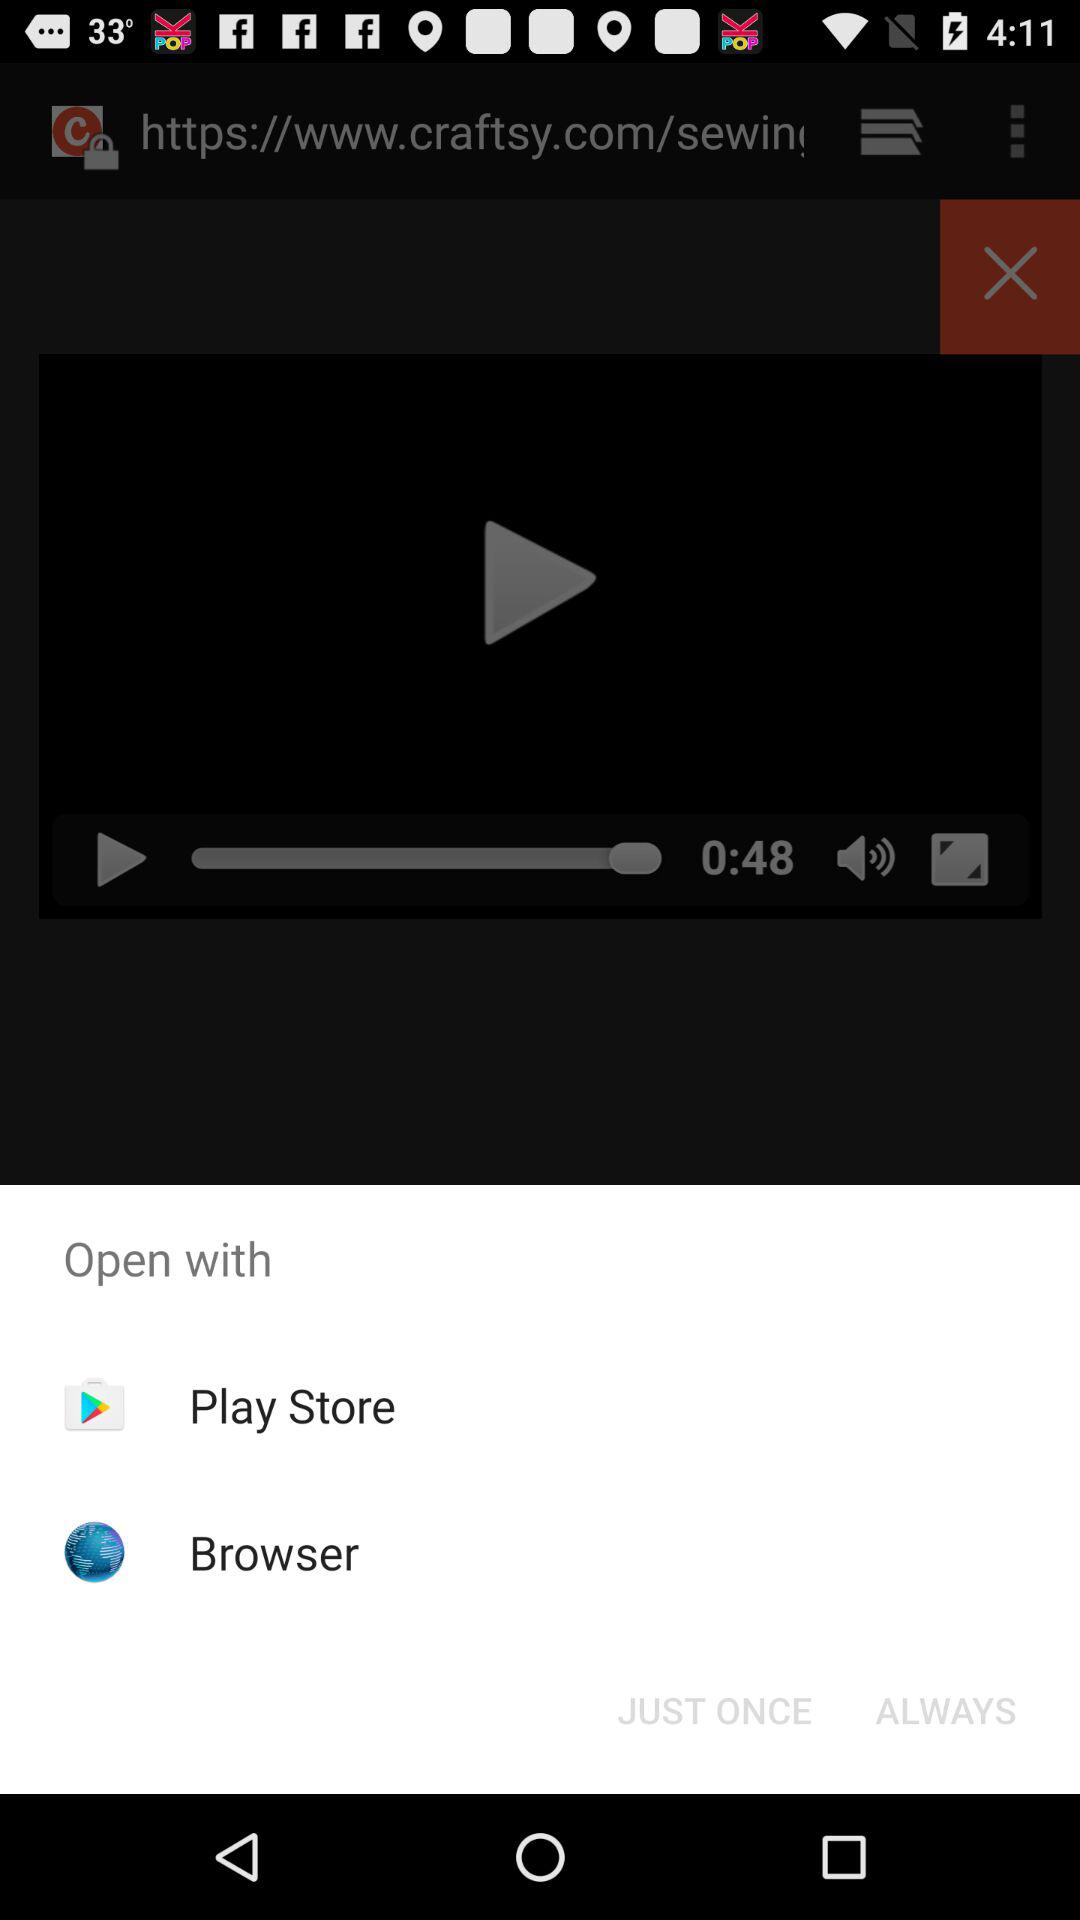What is the time duration? The time duration is 48 seconds. 